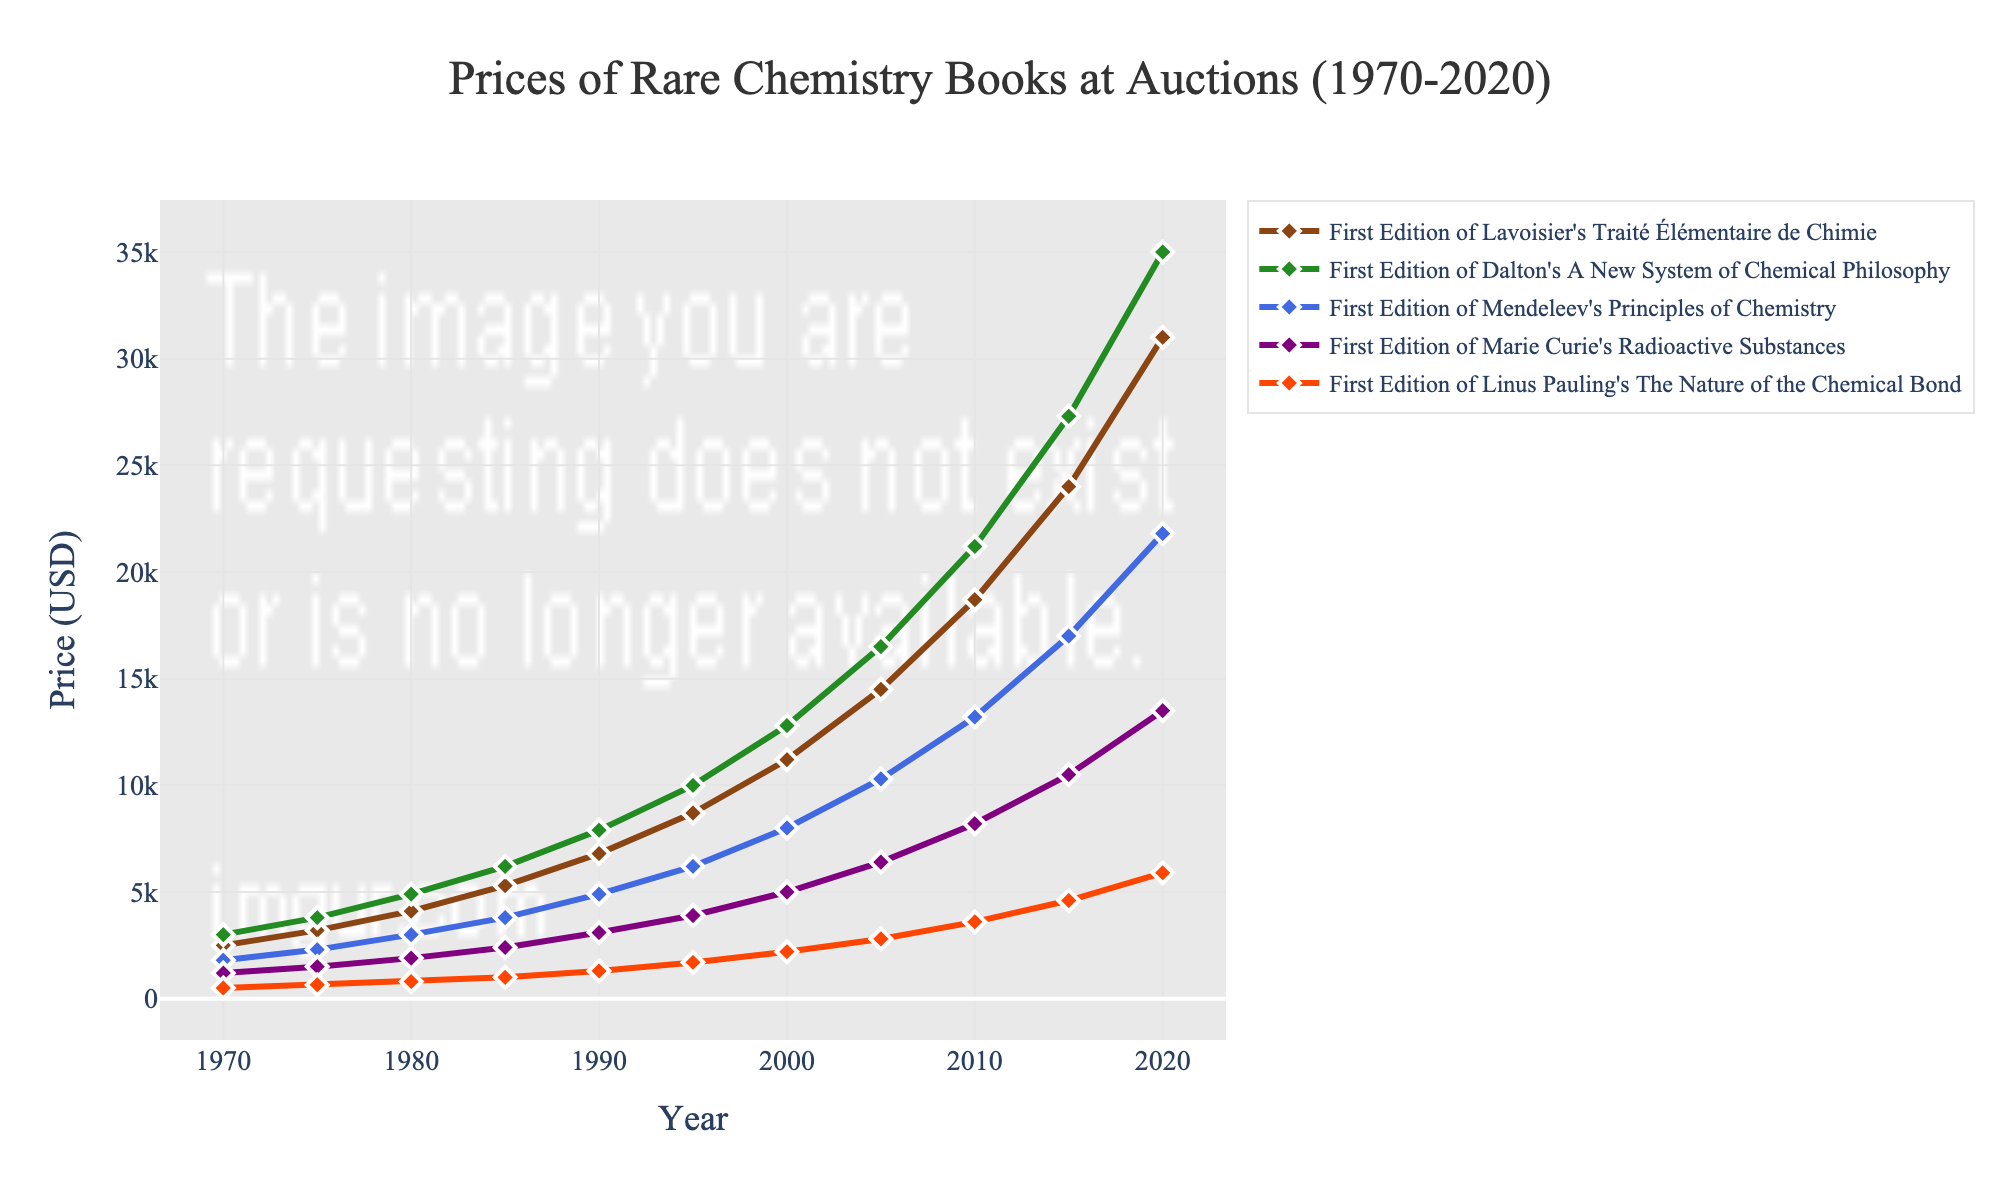Which book's price increased the most from 1970 to 2020? To determine the book with the highest price increase, calculate the price difference for each book between 1970 and 2020. The increases are: Lavoisier's: 31000-2500=28500, Dalton's: 35000-3000=32000, Mendeleev's: 21800-1800=20000, Curie's: 13500-1200=12300, Pauling's: 5900-500=5400. Dalton's book increased the most.
Answer: Dalton's A New System of Chemical Philosophy Which book had the highest price in 1985? Refer to the prices in the year 1985 and compare them. Lavoisier's: $5300, Dalton's: $6200, Mendeleev's: $3800, Curie's: $2400, Pauling's: $1000. Dalton's book had the highest price in 1985.
Answer: Dalton's A New System of Chemical Philosophy What is the average price of Marie Curie's book in the years 1990, 2000, and 2010? Add the prices of Marie Curie's book for the years 1990, 2000, and 2010, then divide by 3. The calculation is (3100 + 5000 + 8200)/3 = 16300/3 ≈ 5433.33.
Answer: $5433.33 In which year did Linus Pauling's book first exceed $3000? Observe the prices for Linus Pauling's book and find the first year it exceeded $3000. It reached $3600 in 2010.
Answer: 2010 How much did the price of Lavoisier's book increase between 1995 and 2000? Calculate the price difference of Lavoisier's book between 1995 and 2000. The increase is 11200 - 8700 = 2500.
Answer: $2500 Which book had the steepest price increase between 2005 and 2010? Calculate the price increase for each book from 2005 to 2010 and compare them. Lavoisier's: 18700-14500=4200, Dalton's: 21200-16500=4700, Mendeleev's: 13200-10300=2900, Curie's: 8200-6400=1800, Pauling's: 3600-2800=800. Dalton's book had the steepest increase.
Answer: Dalton's A New System of Chemical Philosophy What's the difference in price between Dalton's book and Mendeleev's book in 2020? Subtract the price of Mendeleev's book from the price of Dalton's book in 2020. The difference is 35000 - 21800 = 13200.
Answer: $13200 In what year did Mendeleev's book price surpass $10000? Identify the year in which Mendeleev's book price is first shown to be more than $10000. The price was $10300 in 2005.
Answer: 2005 Which book had the lowest price throughout the entire period? Compare the prices of all the books from 1970 to 2020, identify the book with the lowest price. Linus Pauling's book consistently had the lowest price throughout the entire period.
Answer: The Nature of the Chemical Bond by Linus Pauling 